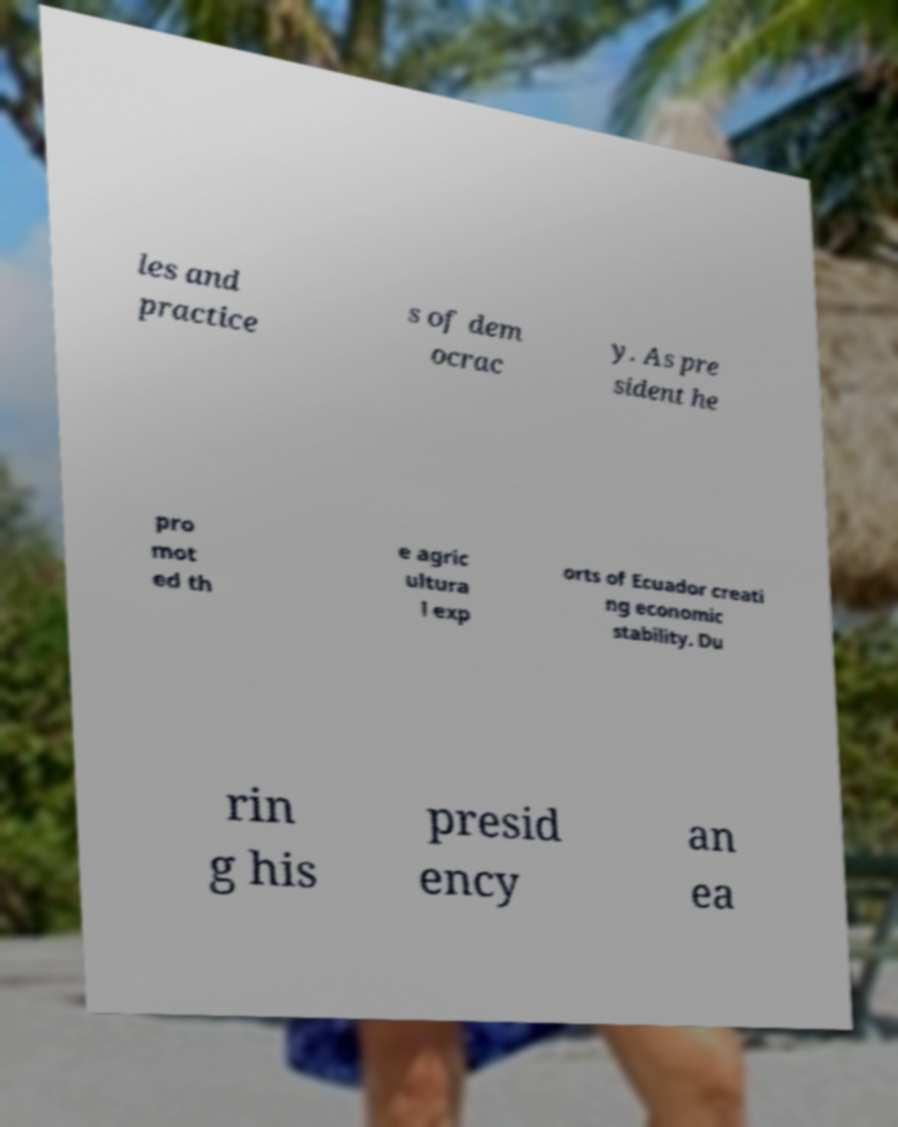Can you read and provide the text displayed in the image?This photo seems to have some interesting text. Can you extract and type it out for me? les and practice s of dem ocrac y. As pre sident he pro mot ed th e agric ultura l exp orts of Ecuador creati ng economic stability. Du rin g his presid ency an ea 